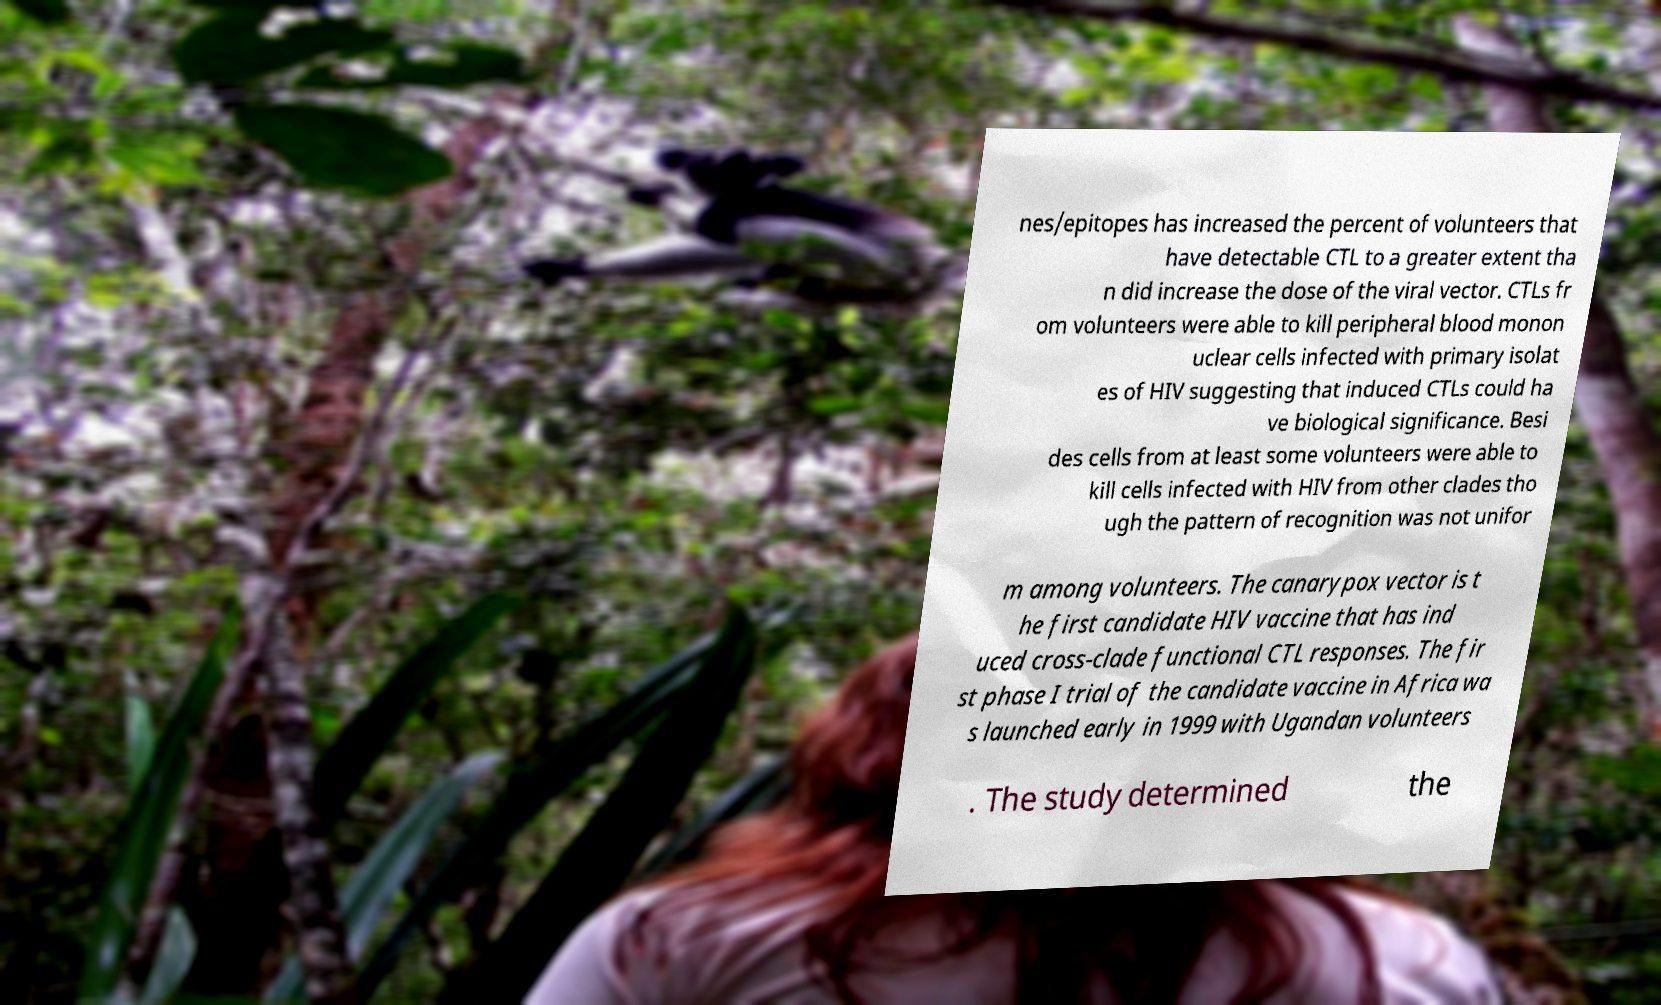Can you read and provide the text displayed in the image?This photo seems to have some interesting text. Can you extract and type it out for me? nes/epitopes has increased the percent of volunteers that have detectable CTL to a greater extent tha n did increase the dose of the viral vector. CTLs fr om volunteers were able to kill peripheral blood monon uclear cells infected with primary isolat es of HIV suggesting that induced CTLs could ha ve biological significance. Besi des cells from at least some volunteers were able to kill cells infected with HIV from other clades tho ugh the pattern of recognition was not unifor m among volunteers. The canarypox vector is t he first candidate HIV vaccine that has ind uced cross-clade functional CTL responses. The fir st phase I trial of the candidate vaccine in Africa wa s launched early in 1999 with Ugandan volunteers . The study determined the 